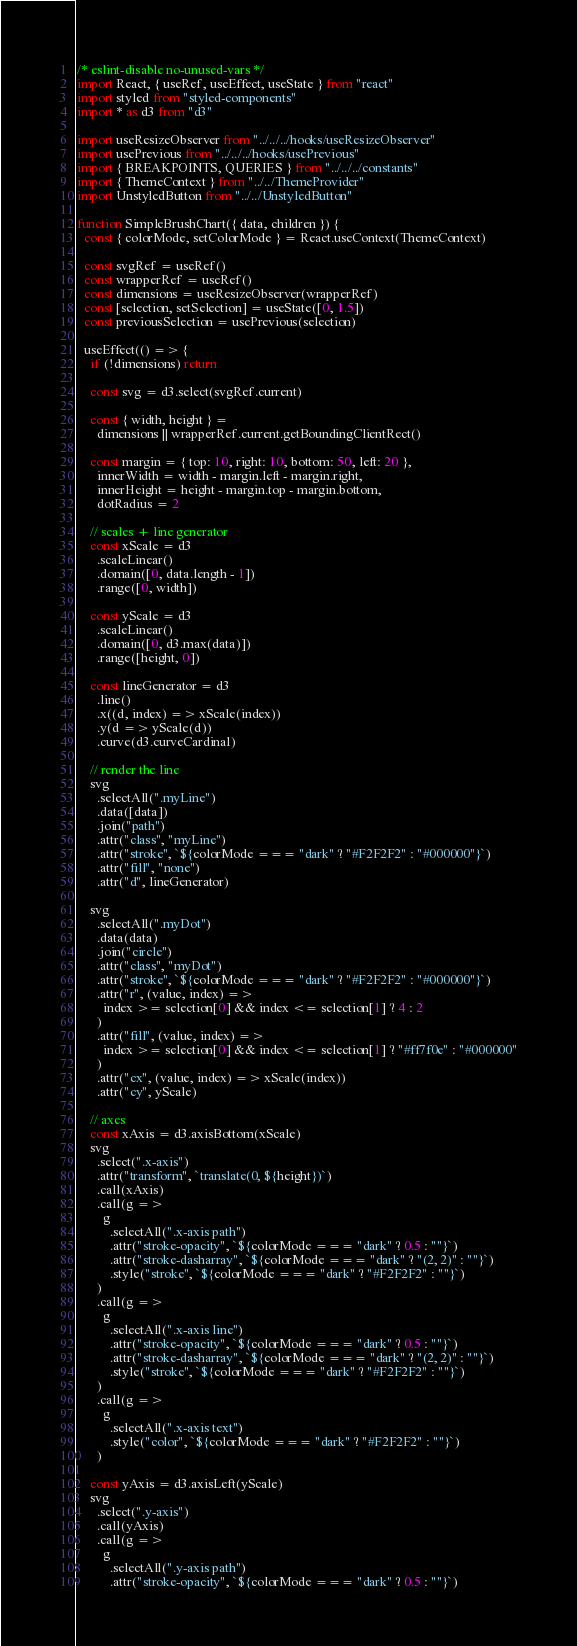<code> <loc_0><loc_0><loc_500><loc_500><_JavaScript_>/* eslint-disable no-unused-vars */
import React, { useRef, useEffect, useState } from "react"
import styled from "styled-components"
import * as d3 from "d3"

import useResizeObserver from "../../../hooks/useResizeObserver"
import usePrevious from "../../../hooks/usePrevious"
import { BREAKPOINTS, QUERIES } from "../../../constants"
import { ThemeContext } from "../../ThemeProvider"
import UnstyledButton from "../../UnstyledButton"

function SimpleBrushChart({ data, children }) {
  const { colorMode, setColorMode } = React.useContext(ThemeContext)

  const svgRef = useRef()
  const wrapperRef = useRef()
  const dimensions = useResizeObserver(wrapperRef)
  const [selection, setSelection] = useState([0, 1.5])
  const previousSelection = usePrevious(selection)

  useEffect(() => {
    if (!dimensions) return

    const svg = d3.select(svgRef.current)

    const { width, height } =
      dimensions || wrapperRef.current.getBoundingClientRect()

    const margin = { top: 10, right: 10, bottom: 50, left: 20 },
      innerWidth = width - margin.left - margin.right,
      innerHeight = height - margin.top - margin.bottom,
      dotRadius = 2

    // scales + line generator
    const xScale = d3
      .scaleLinear()
      .domain([0, data.length - 1])
      .range([0, width])

    const yScale = d3
      .scaleLinear()
      .domain([0, d3.max(data)])
      .range([height, 0])

    const lineGenerator = d3
      .line()
      .x((d, index) => xScale(index))
      .y(d => yScale(d))
      .curve(d3.curveCardinal)

    // render the line
    svg
      .selectAll(".myLine")
      .data([data])
      .join("path")
      .attr("class", "myLine")
      .attr("stroke", `${colorMode === "dark" ? "#F2F2F2" : "#000000"}`)
      .attr("fill", "none")
      .attr("d", lineGenerator)

    svg
      .selectAll(".myDot")
      .data(data)
      .join("circle")
      .attr("class", "myDot")
      .attr("stroke", `${colorMode === "dark" ? "#F2F2F2" : "#000000"}`)
      .attr("r", (value, index) =>
        index >= selection[0] && index <= selection[1] ? 4 : 2
      )
      .attr("fill", (value, index) =>
        index >= selection[0] && index <= selection[1] ? "#ff7f0e" : "#000000"
      )
      .attr("cx", (value, index) => xScale(index))
      .attr("cy", yScale)

    // axes
    const xAxis = d3.axisBottom(xScale)
    svg
      .select(".x-axis")
      .attr("transform", `translate(0, ${height})`)
      .call(xAxis)
      .call(g =>
        g
          .selectAll(".x-axis path")
          .attr("stroke-opacity", `${colorMode === "dark" ? 0.5 : ""}`)
          .attr("stroke-dasharray", `${colorMode === "dark" ? "(2, 2)" : ""}`)
          .style("stroke", `${colorMode === "dark" ? "#F2F2F2" : ""}`)
      )
      .call(g =>
        g
          .selectAll(".x-axis line")
          .attr("stroke-opacity", `${colorMode === "dark" ? 0.5 : ""}`)
          .attr("stroke-dasharray", `${colorMode === "dark" ? "(2, 2)" : ""}`)
          .style("stroke", `${colorMode === "dark" ? "#F2F2F2" : ""}`)
      )
      .call(g =>
        g
          .selectAll(".x-axis text")
          .style("color", `${colorMode === "dark" ? "#F2F2F2" : ""}`)
      )

    const yAxis = d3.axisLeft(yScale)
    svg
      .select(".y-axis")
      .call(yAxis)
      .call(g =>
        g
          .selectAll(".y-axis path")
          .attr("stroke-opacity", `${colorMode === "dark" ? 0.5 : ""}`)</code> 